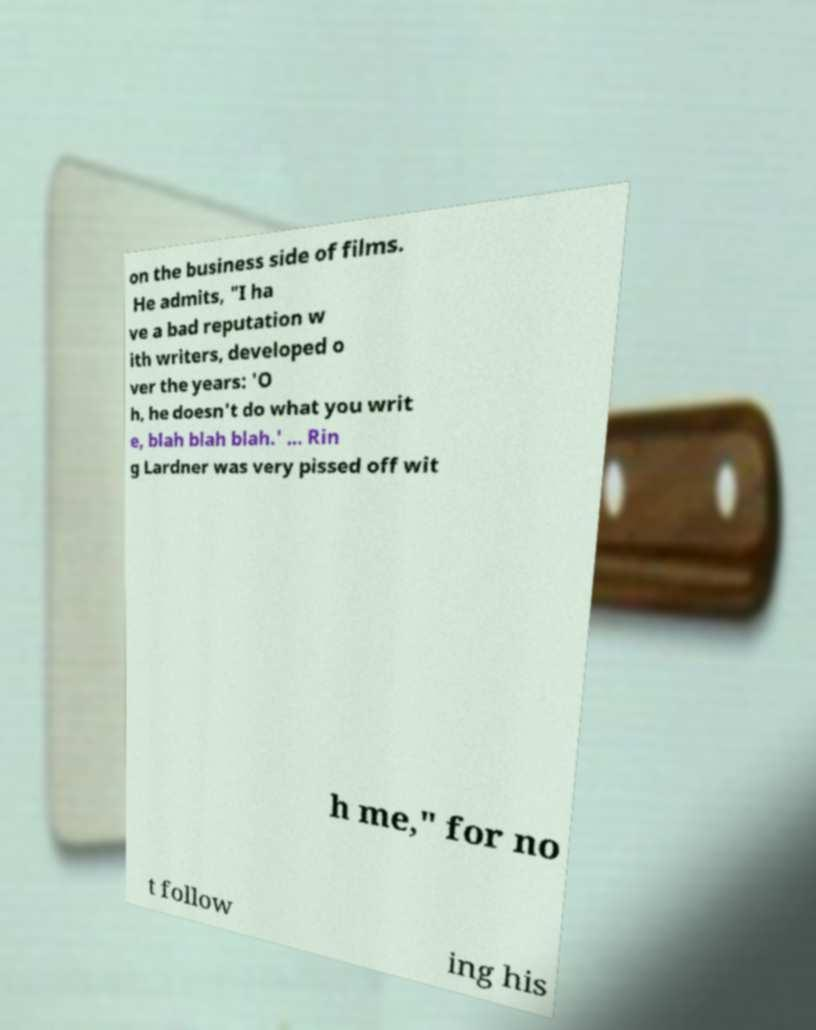There's text embedded in this image that I need extracted. Can you transcribe it verbatim? on the business side of films. He admits, "I ha ve a bad reputation w ith writers, developed o ver the years: 'O h, he doesn't do what you writ e, blah blah blah.' ... Rin g Lardner was very pissed off wit h me," for no t follow ing his 